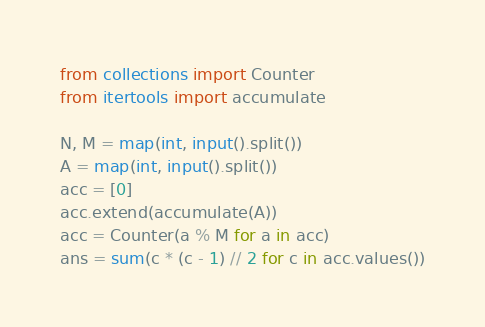<code> <loc_0><loc_0><loc_500><loc_500><_Python_>from collections import Counter
from itertools import accumulate

N, M = map(int, input().split())
A = map(int, input().split())
acc = [0] 
acc.extend(accumulate(A))
acc = Counter(a % M for a in acc)
ans = sum(c * (c - 1) // 2 for c in acc.values())</code> 